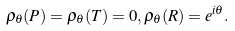<formula> <loc_0><loc_0><loc_500><loc_500>\rho _ { \theta } ( P ) = \rho _ { \theta } ( T ) = 0 , \rho _ { \theta } ( R ) = e ^ { i \theta } .</formula> 